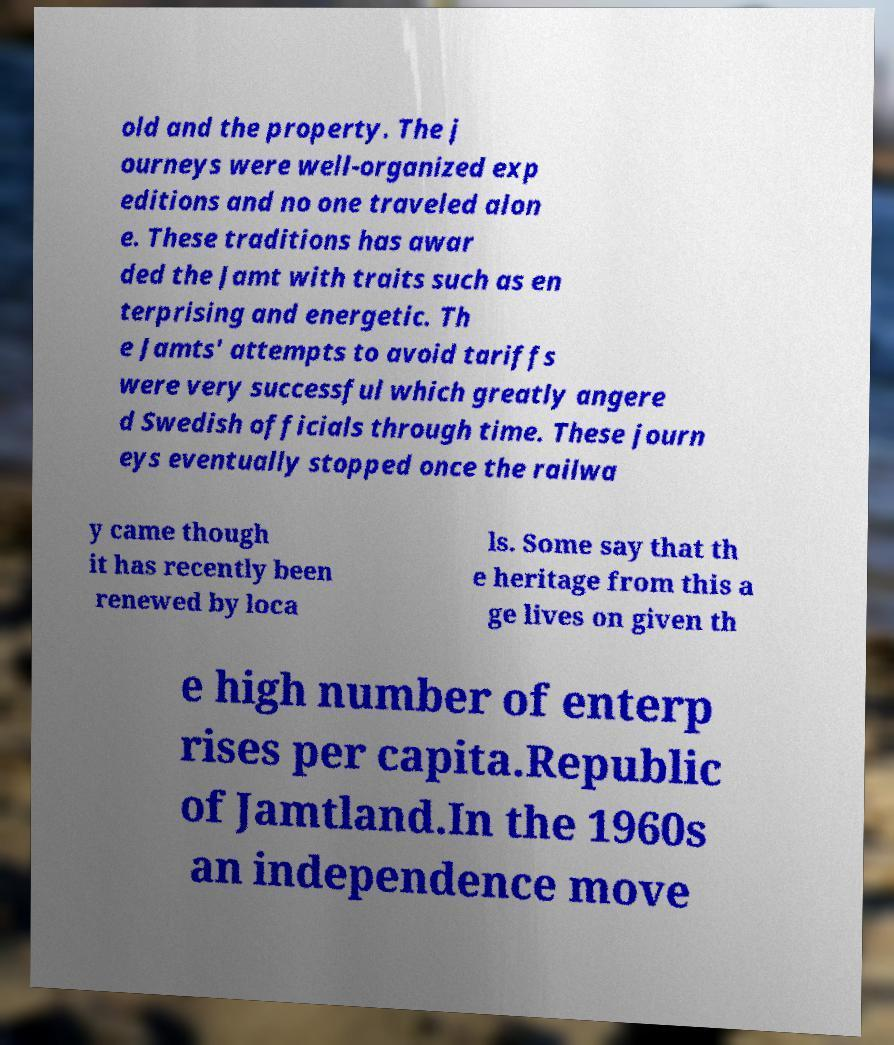Please identify and transcribe the text found in this image. old and the property. The j ourneys were well-organized exp editions and no one traveled alon e. These traditions has awar ded the Jamt with traits such as en terprising and energetic. Th e Jamts' attempts to avoid tariffs were very successful which greatly angere d Swedish officials through time. These journ eys eventually stopped once the railwa y came though it has recently been renewed by loca ls. Some say that th e heritage from this a ge lives on given th e high number of enterp rises per capita.Republic of Jamtland.In the 1960s an independence move 